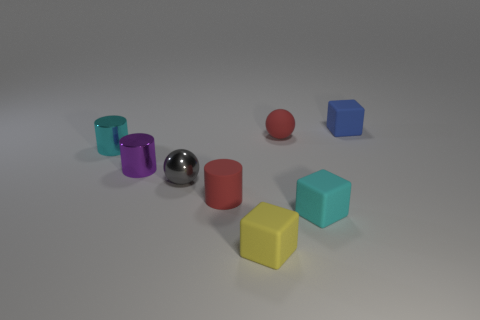Is the number of red balls that are right of the red ball the same as the number of tiny cyan matte objects right of the cyan cube?
Keep it short and to the point. Yes. What material is the small yellow thing?
Offer a very short reply. Rubber. There is a sphere that is the same size as the gray thing; what is its color?
Your answer should be compact. Red. There is a cyan object in front of the gray shiny object; is there a tiny red rubber ball that is to the right of it?
Your answer should be very brief. No. What number of blocks are metal objects or small red metal things?
Provide a short and direct response. 0. How big is the red object that is on the right side of the small red rubber thing that is on the left side of the red object to the right of the red rubber cylinder?
Keep it short and to the point. Small. Are there any blue rubber blocks behind the tiny red cylinder?
Your answer should be compact. Yes. There is a thing that is the same color as the matte cylinder; what shape is it?
Keep it short and to the point. Sphere. How many objects are gray things that are in front of the blue thing or big brown matte objects?
Ensure brevity in your answer.  1. There is a red ball that is made of the same material as the cyan cube; what size is it?
Your answer should be very brief. Small. 